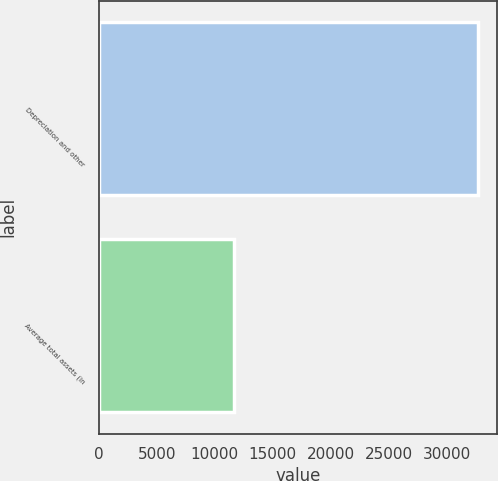Convert chart. <chart><loc_0><loc_0><loc_500><loc_500><bar_chart><fcel>Depreciation and other<fcel>Average total assets (in<nl><fcel>32734<fcel>11705<nl></chart> 